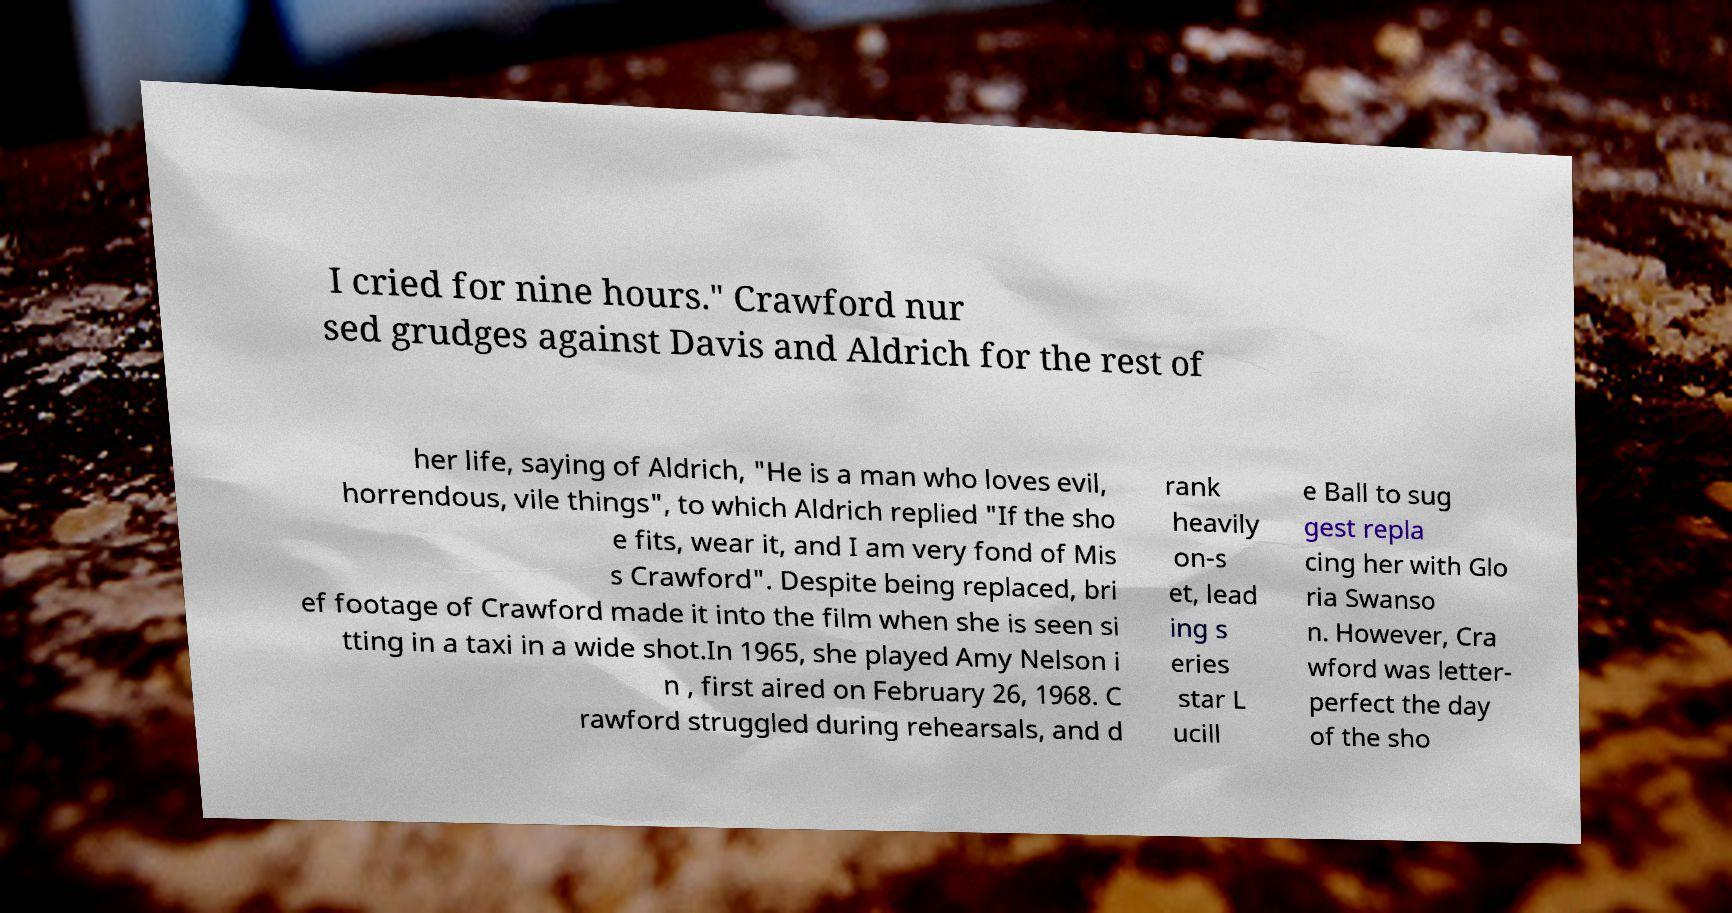I need the written content from this picture converted into text. Can you do that? I cried for nine hours." Crawford nur sed grudges against Davis and Aldrich for the rest of her life, saying of Aldrich, "He is a man who loves evil, horrendous, vile things", to which Aldrich replied "If the sho e fits, wear it, and I am very fond of Mis s Crawford". Despite being replaced, bri ef footage of Crawford made it into the film when she is seen si tting in a taxi in a wide shot.In 1965, she played Amy Nelson i n , first aired on February 26, 1968. C rawford struggled during rehearsals, and d rank heavily on-s et, lead ing s eries star L ucill e Ball to sug gest repla cing her with Glo ria Swanso n. However, Cra wford was letter- perfect the day of the sho 